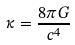Convert formula to latex. <formula><loc_0><loc_0><loc_500><loc_500>\kappa = \frac { 8 \pi G } { c ^ { 4 } }</formula> 